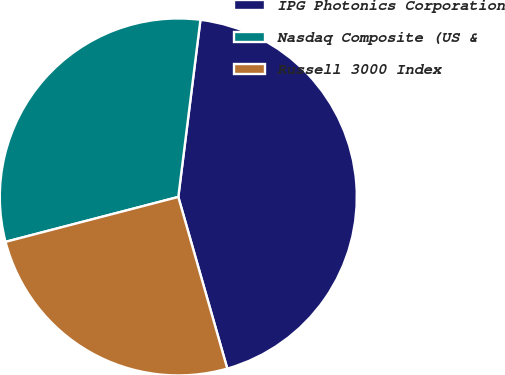Convert chart. <chart><loc_0><loc_0><loc_500><loc_500><pie_chart><fcel>IPG Photonics Corporation<fcel>Nasdaq Composite (US &<fcel>Russell 3000 Index<nl><fcel>43.6%<fcel>31.03%<fcel>25.38%<nl></chart> 